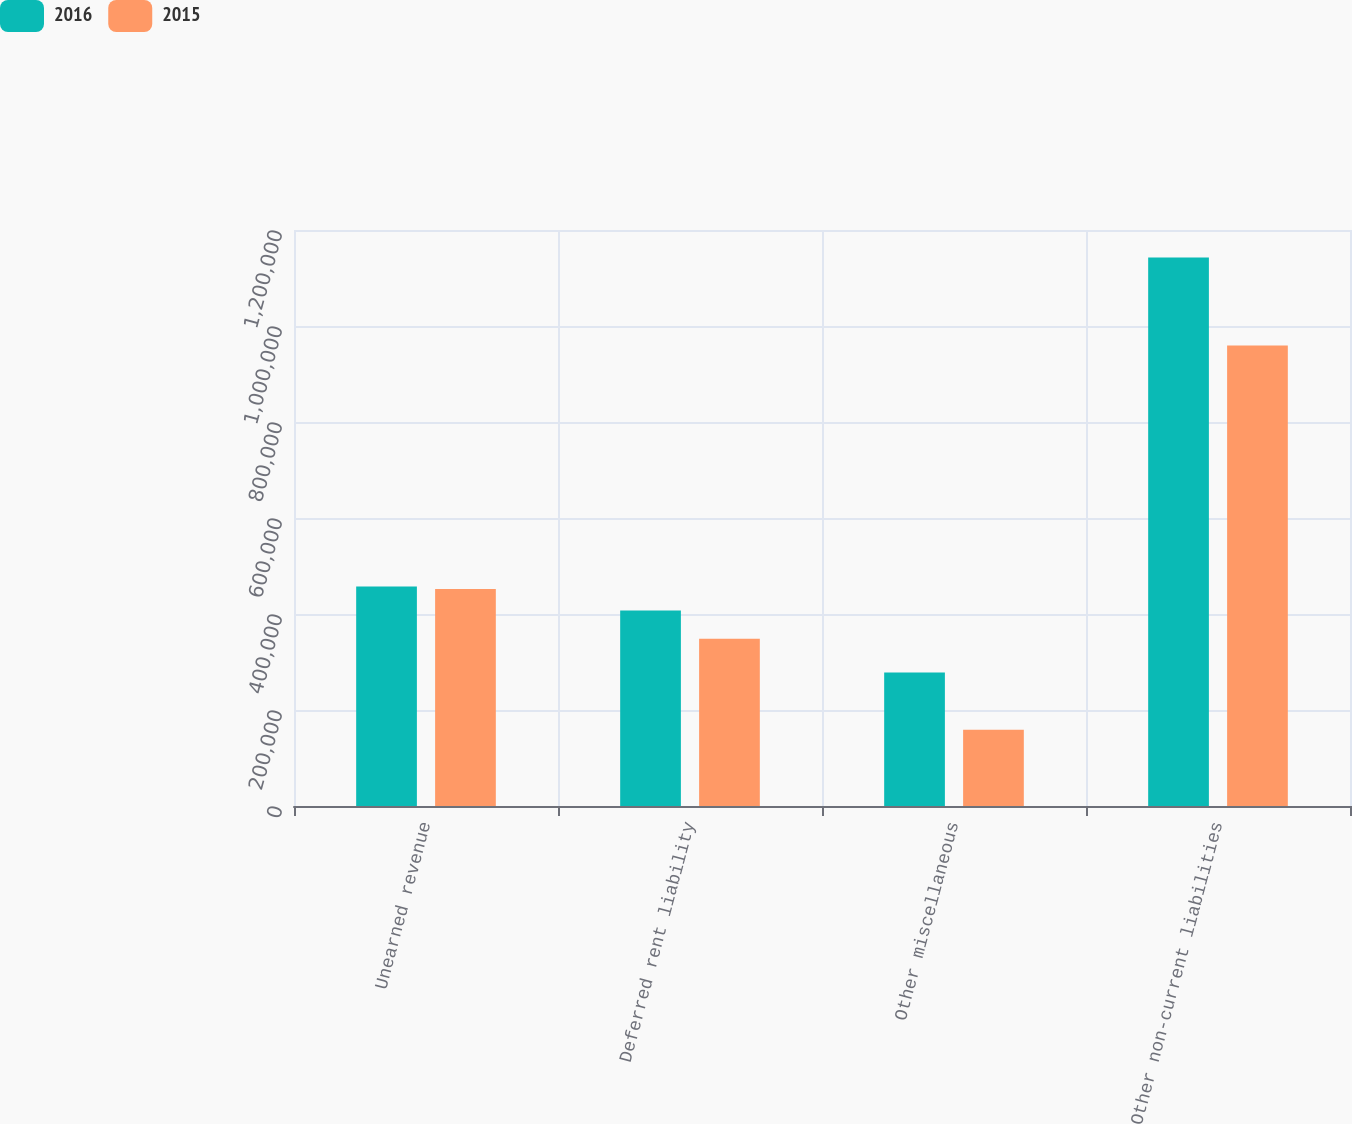<chart> <loc_0><loc_0><loc_500><loc_500><stacked_bar_chart><ecel><fcel>Unearned revenue<fcel>Deferred rent liability<fcel>Other miscellaneous<fcel>Other non-current liabilities<nl><fcel>2016<fcel>457272<fcel>407157<fcel>278294<fcel>1.14272e+06<nl><fcel>2015<fcel>451844<fcel>348532<fcel>158973<fcel>959349<nl></chart> 